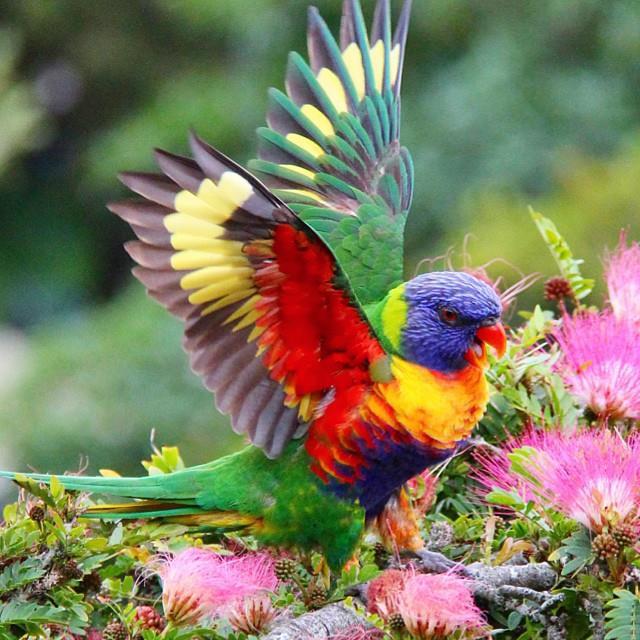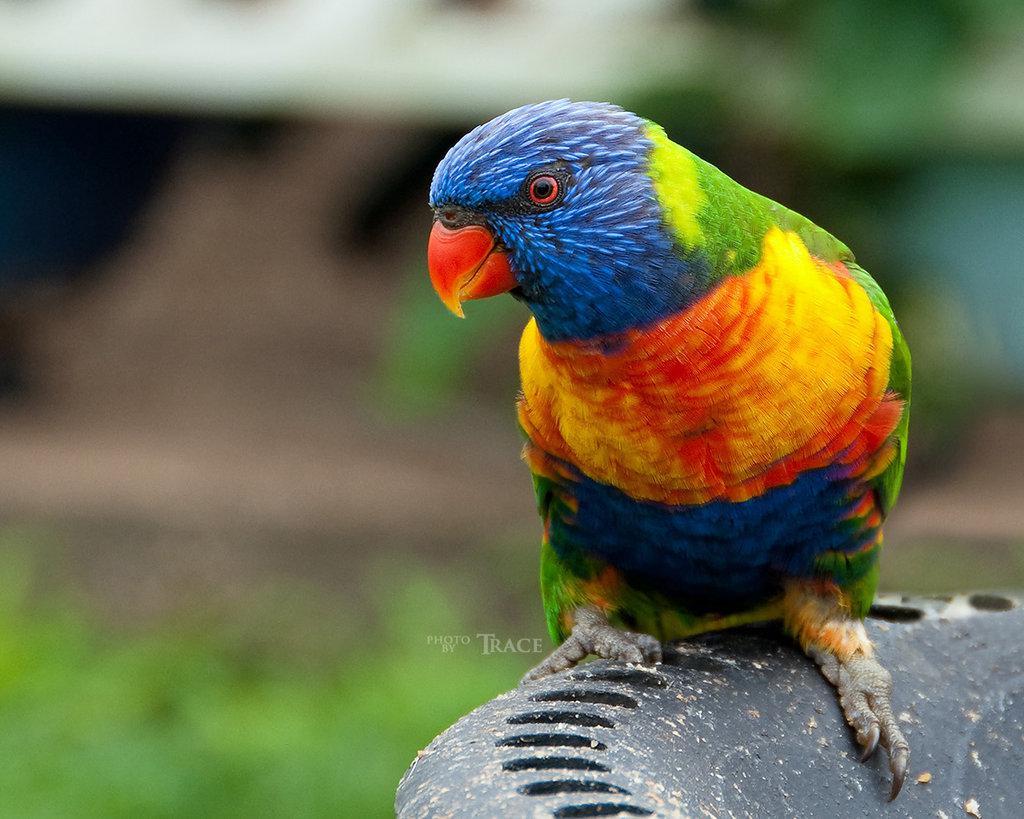The first image is the image on the left, the second image is the image on the right. Evaluate the accuracy of this statement regarding the images: "There are 3 birds in the image pair". Is it true? Answer yes or no. No. The first image is the image on the left, the second image is the image on the right. Analyze the images presented: Is the assertion "A single bird is perched on the edge of a bowl and facing left in one image." valid? Answer yes or no. Yes. 